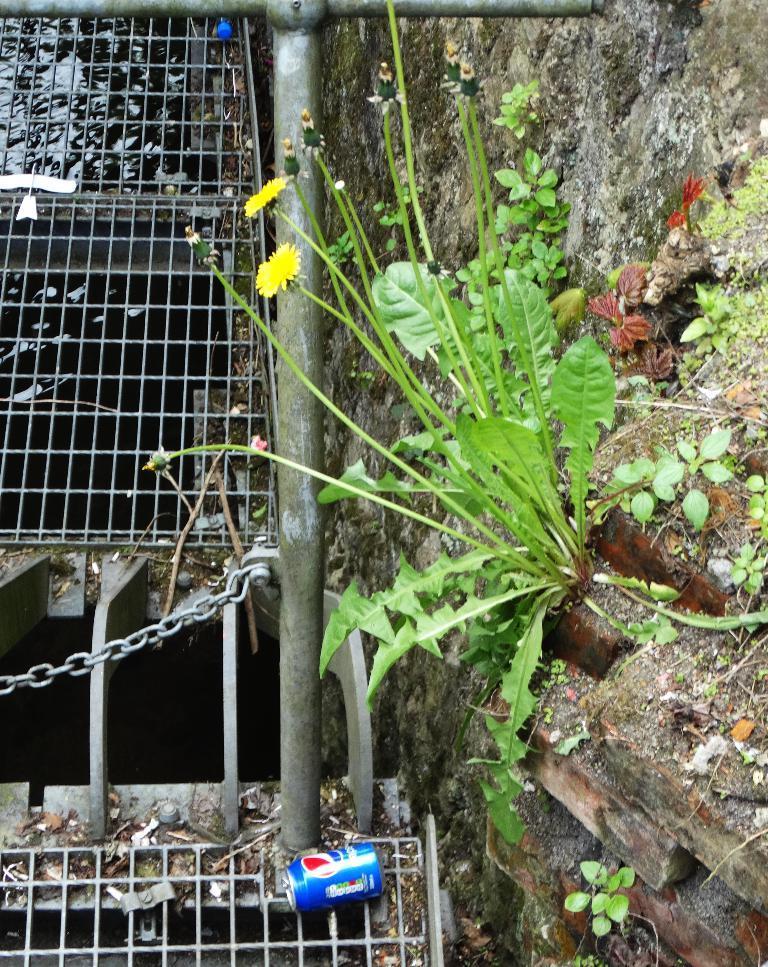Describe this image in one or two sentences. In this image we can see a wall. There are many plants in the image. There are flowers to the plants. There is a canal. There is a metallic object in the image. There is a tin in the image. 